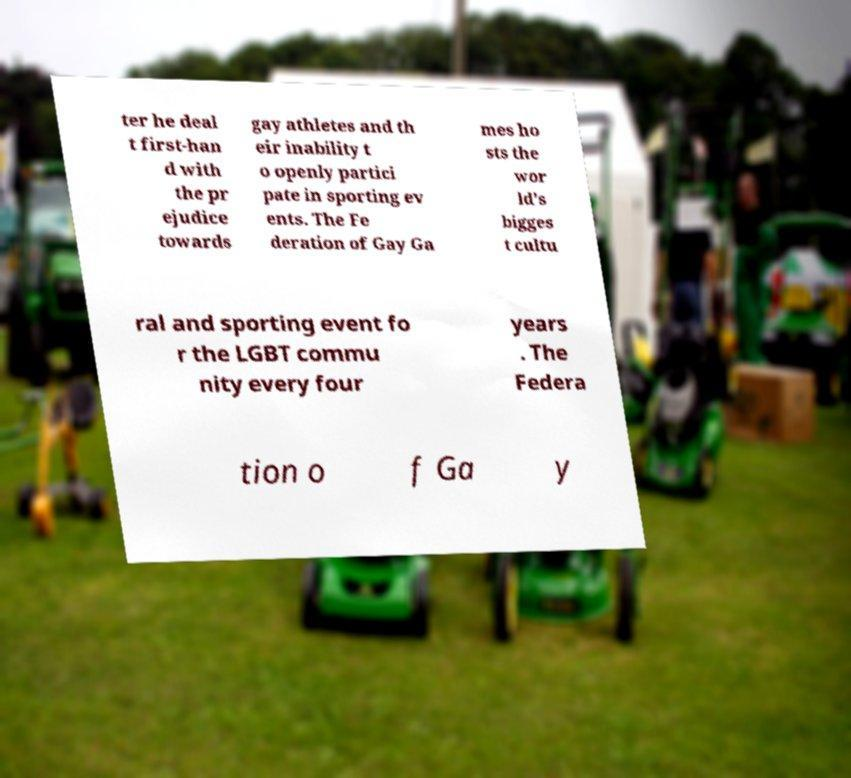Can you read and provide the text displayed in the image?This photo seems to have some interesting text. Can you extract and type it out for me? ter he deal t first-han d with the pr ejudice towards gay athletes and th eir inability t o openly partici pate in sporting ev ents. The Fe deration of Gay Ga mes ho sts the wor ld's bigges t cultu ral and sporting event fo r the LGBT commu nity every four years . The Federa tion o f Ga y 